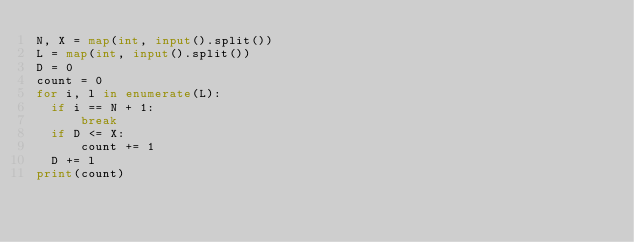<code> <loc_0><loc_0><loc_500><loc_500><_Python_>N, X = map(int, input().split())
L = map(int, input().split())
D = 0
count = 0
for i, l in enumerate(L):
  if i == N + 1:
      break
  if D <= X:
      count += 1
  D += l
print(count)</code> 